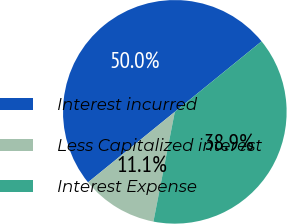<chart> <loc_0><loc_0><loc_500><loc_500><pie_chart><fcel>Interest incurred<fcel>Less Capitalized interest<fcel>Interest Expense<nl><fcel>50.0%<fcel>11.08%<fcel>38.92%<nl></chart> 